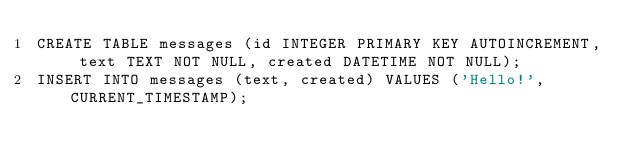Convert code to text. <code><loc_0><loc_0><loc_500><loc_500><_SQL_>CREATE TABLE messages (id INTEGER PRIMARY KEY AUTOINCREMENT, text TEXT NOT NULL, created DATETIME NOT NULL);
INSERT INTO messages (text, created) VALUES ('Hello!', CURRENT_TIMESTAMP);</code> 